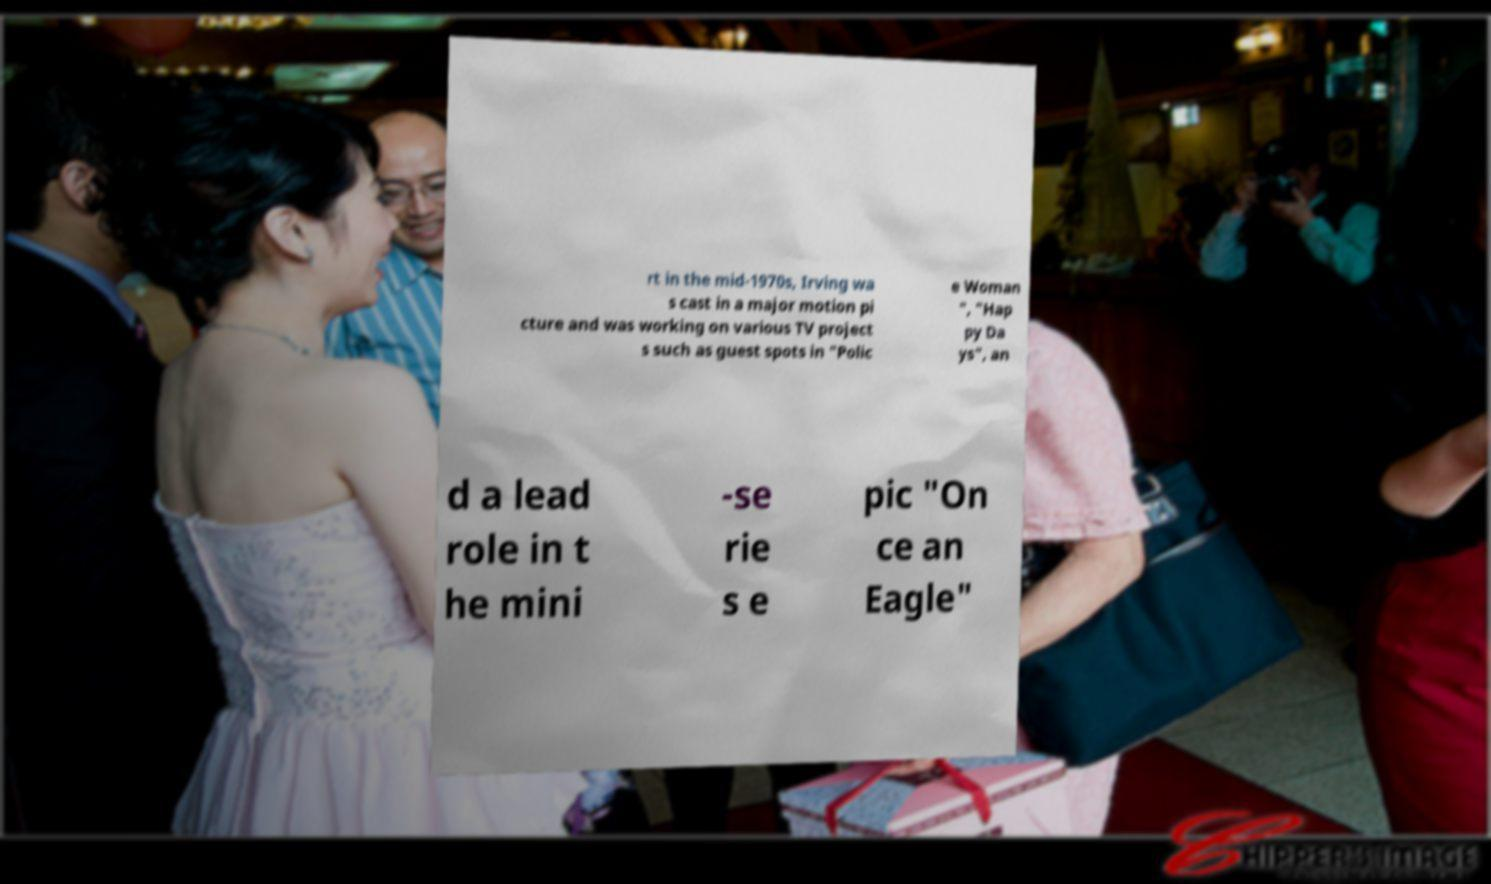Could you assist in decoding the text presented in this image and type it out clearly? rt in the mid-1970s, Irving wa s cast in a major motion pi cture and was working on various TV project s such as guest spots in "Polic e Woman ", "Hap py Da ys", an d a lead role in t he mini -se rie s e pic "On ce an Eagle" 